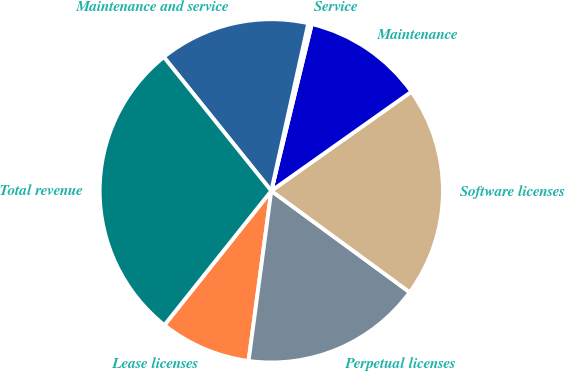Convert chart to OTSL. <chart><loc_0><loc_0><loc_500><loc_500><pie_chart><fcel>Lease licenses<fcel>Perpetual licenses<fcel>Software licenses<fcel>Maintenance<fcel>Service<fcel>Maintenance and service<fcel>Total revenue<nl><fcel>8.59%<fcel>17.05%<fcel>19.87%<fcel>11.41%<fcel>0.33%<fcel>14.23%<fcel>28.53%<nl></chart> 